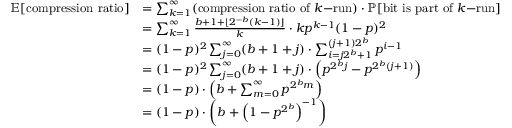Convert formula to latex. <formula><loc_0><loc_0><loc_500><loc_500>{ \begin{array} { r l } { \mathbb { E } [ { c o m p r e s s i o n r a t i o } ] } & { = \sum _ { k = 1 } ^ { \infty } ( { c o m p r e s s i o n r a t i o o f } k { - r u n } ) \cdot \mathbb { P } [ { b i t i s p a r t o f } k { - r u n } ] } \\ & { = \sum _ { k = 1 } ^ { \infty } { \frac { b + 1 + \lfloor 2 ^ { - b } ( k - 1 ) \rfloor } { k } } \cdot k p ^ { k - 1 } ( 1 - p ) ^ { 2 } } \\ & { = ( 1 - p ) ^ { 2 } \sum _ { j = 0 } ^ { \infty } ( b + 1 + j ) \cdot \sum _ { i = j 2 ^ { b } + 1 } ^ { ( j + 1 ) 2 ^ { b } } p ^ { i - 1 } } \\ & { = ( 1 - p ) ^ { 2 } \sum _ { j = 0 } ^ { \infty } ( b + 1 + j ) \cdot \left ( p ^ { 2 ^ { b } j } - p ^ { 2 ^ { b } ( j + 1 ) } \right ) } \\ & { = ( 1 - p ) \cdot \left ( b + \sum _ { m = 0 } ^ { \infty } p ^ { 2 ^ { b } m } \right ) } \\ & { = ( 1 - p ) \cdot \left ( b + { \left ( 1 - p ^ { 2 ^ { b } } \right ) } ^ { - 1 } \right ) } \end{array} }</formula> 